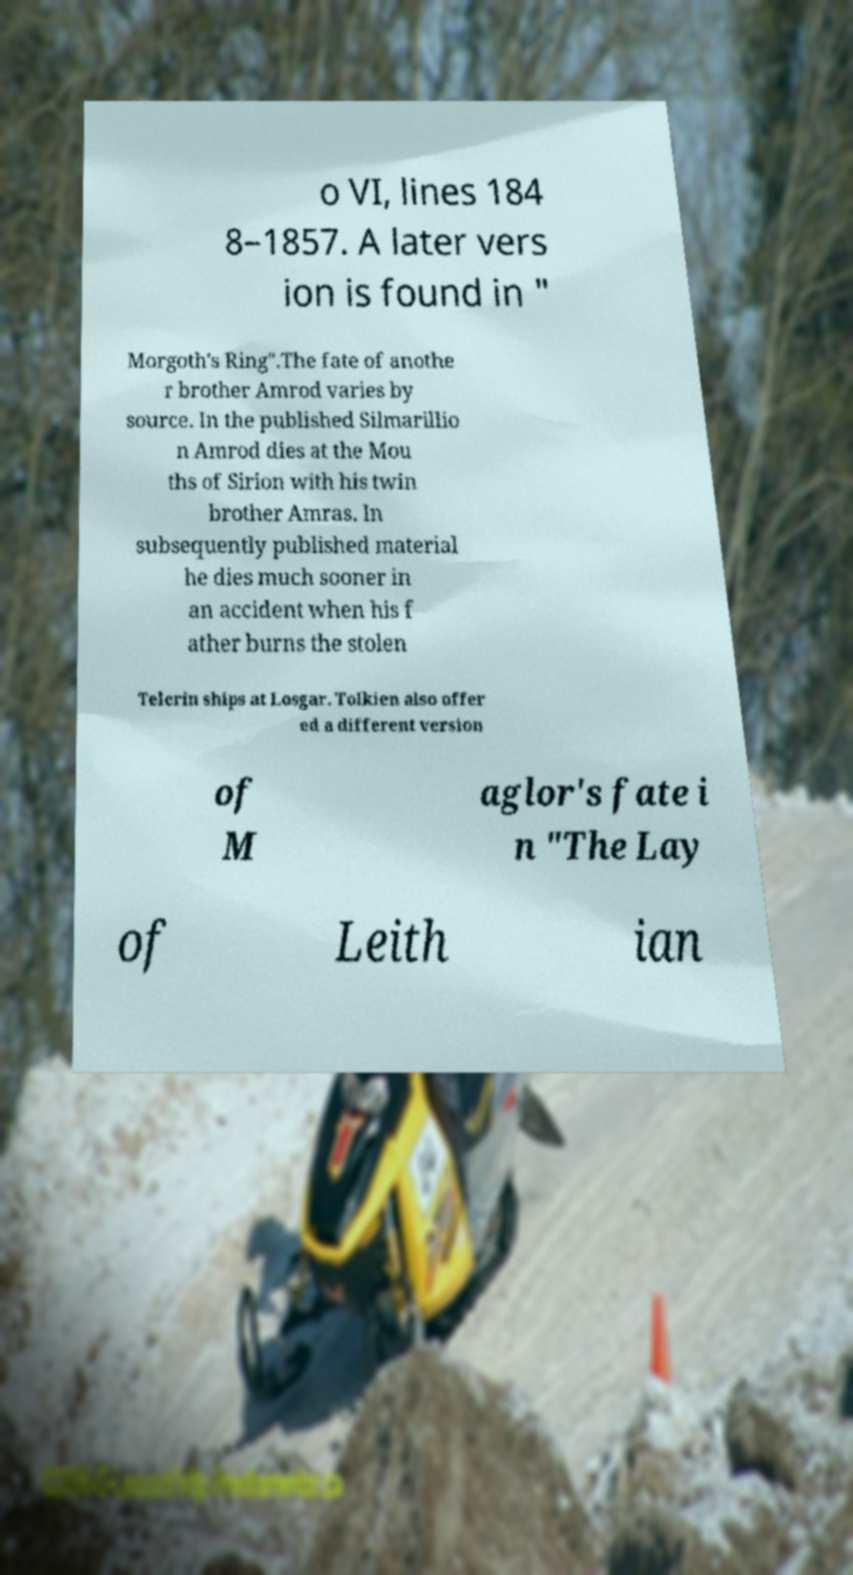Please read and relay the text visible in this image. What does it say? o VI, lines 184 8–1857. A later vers ion is found in " Morgoth's Ring".The fate of anothe r brother Amrod varies by source. In the published Silmarillio n Amrod dies at the Mou ths of Sirion with his twin brother Amras. In subsequently published material he dies much sooner in an accident when his f ather burns the stolen Telerin ships at Losgar. Tolkien also offer ed a different version of M aglor's fate i n "The Lay of Leith ian 